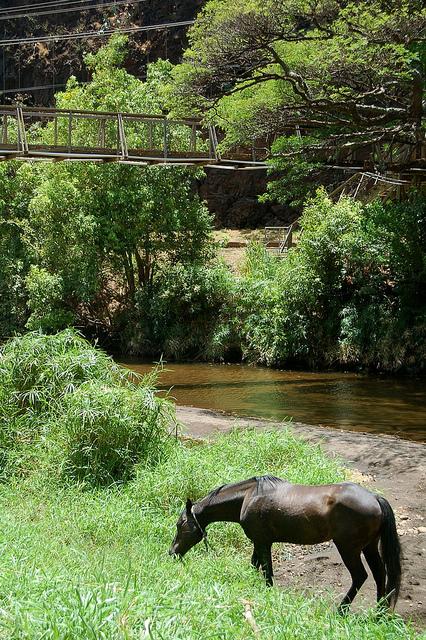How can you tell the water is lower than normal?
Be succinct. Muddy bank. What is the horse doing?
Quick response, please. Eating. Has the bridge been maintained safely?
Concise answer only. No. 